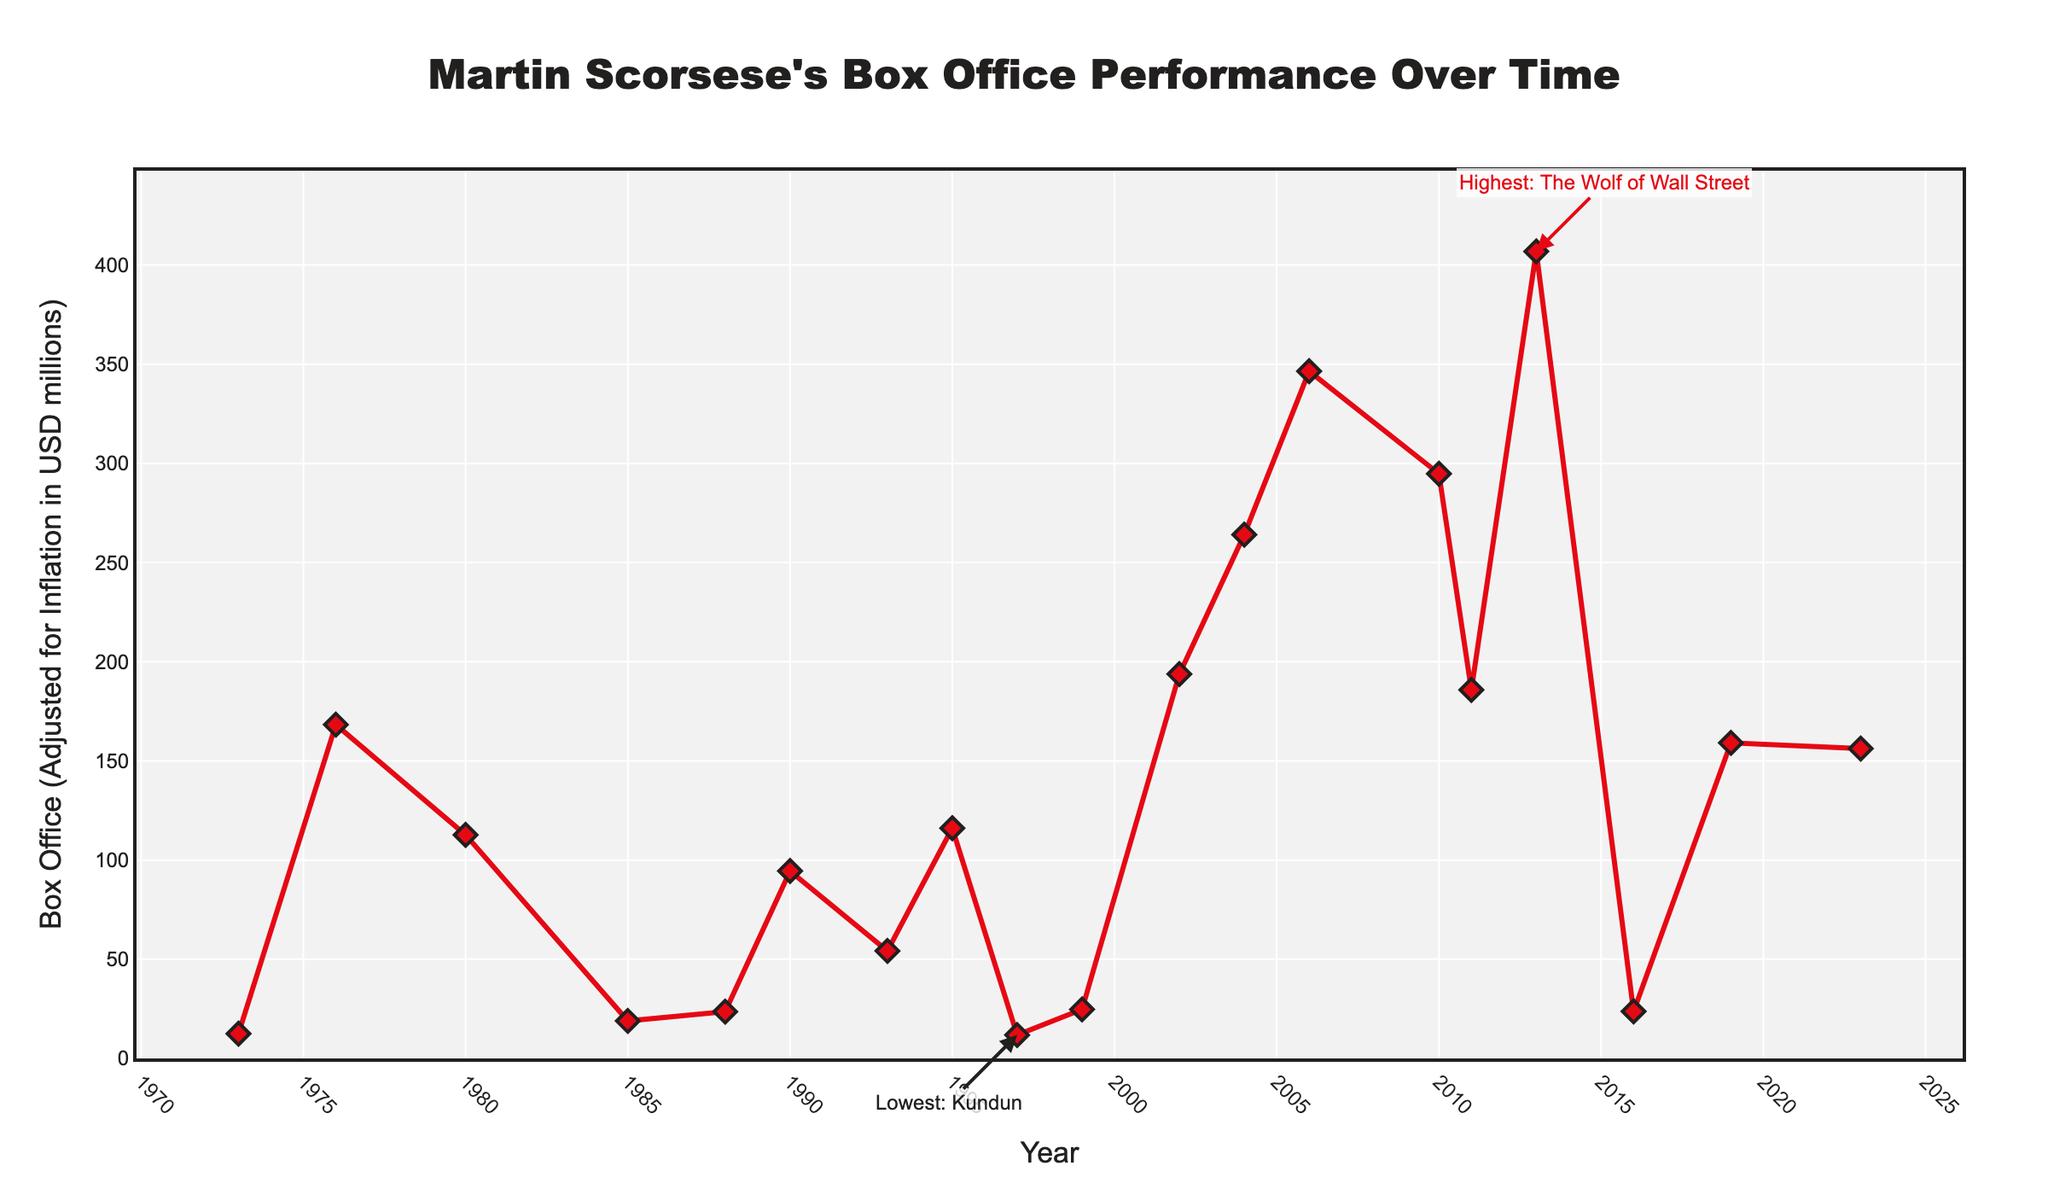What's the highest-grossing Martin Scorsese film according to the chart? The chart has annotations pointing out the highest and lowest-grossing films. The annotation on top of the peak shows that the highest-grossing film is "The Wolf of Wall Street".
Answer: The Wolf of Wall Street What's the lowest-grossing Martin Scorsese film? The chart's annotation at the lowest point indicates that "Kundun" is the lowest-grossing film.
Answer: Kundun Which film had Martin Scorsese's highest box office performance in the 2000s? Looking at the plot for the 2000s period, the highest point is for "The Departed" in 2006.
Answer: The Departed What is the box office difference between "Taxi Driver" and "Mean Streets"? By referring to the specific points for "Taxi Driver" (168.3 million) and "Mean Streets" (12.5 million), we subtract the latter from the former. 168.3 - 12.5 = 155.8.
Answer: 155.8 million Which of Scorsese's films in the 2010s had the lowest box office performance? In the 2010s, the chart shows data points for "Shutter Island", "Hugo", "The Wolf of Wall Street", "Silence", and "The Irishman". The lowest point amongst these is "Silence".
Answer: Silence What is the average box office performance of Martin Scorsese’s films released in the 1980s? The relevant films are "Raging Bull" (112.7 million) and "After Hours" (18.9 million). The average is calculated as (112.7 + 18.9) / 2 = 65.8.
Answer: 65.8 million How many films released before 2000 have a box office performance above 100 million? Observing the chart, "Taxi Driver" (168.3 million), "Raging Bull" (112.7 million), and "Casino" (116.1 million) are above 100 million before 2000. The total count is three.
Answer: 3 Compare the box office performance of "Gangs of New York" and "The Aviator". Which one performed better? Looking at the chart points, "The Aviator" (2004) performed better with 264.1 million compared to "Gangs of New York" with 193.8 million.
Answer: The Aviator What trend can be observed in Scorsese's box office performance from 2006 to 2013? From 2006 to 2013, the performance shows a rising trend: "The Departed" (346.5 million), "Shutter Island" (294.8 million), and "The Wolf of Wall Street" (406.9 million).
Answer: Increasing What was the box office performance of Scorsese's first film in the 1990s? The first film in the 1990s on the chart is "Goodfellas" from 1990, with a box office performance of 94.5 million.
Answer: 94.5 million 